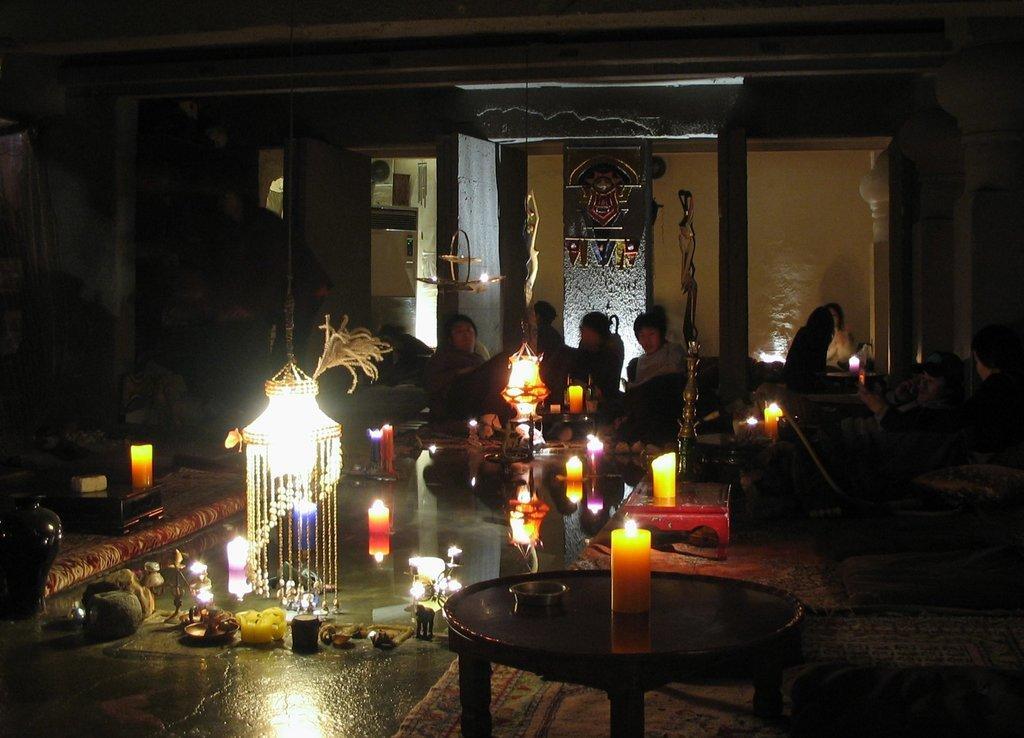Describe this image in one or two sentences. In this image I see few people, candles. lights and the wall. 